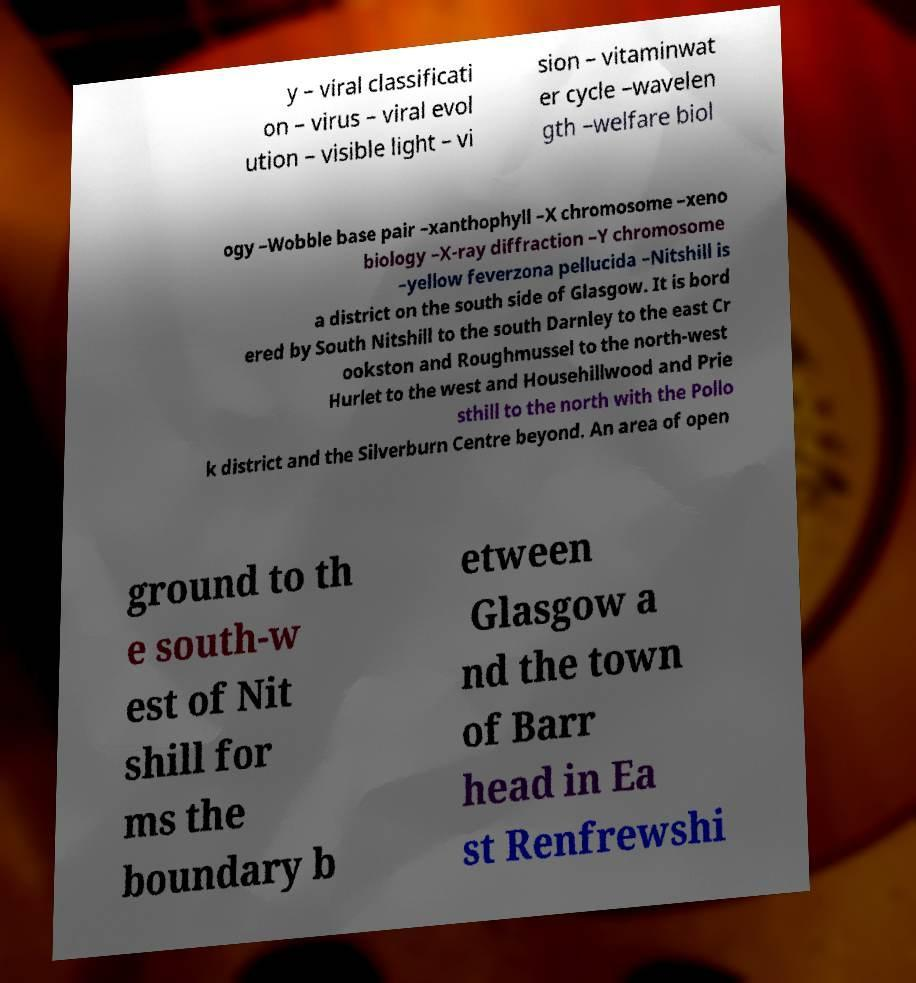Please identify and transcribe the text found in this image. y – viral classificati on – virus – viral evol ution – visible light – vi sion – vitaminwat er cycle –wavelen gth –welfare biol ogy –Wobble base pair –xanthophyll –X chromosome –xeno biology –X-ray diffraction –Y chromosome –yellow feverzona pellucida –Nitshill is a district on the south side of Glasgow. It is bord ered by South Nitshill to the south Darnley to the east Cr ookston and Roughmussel to the north-west Hurlet to the west and Househillwood and Prie sthill to the north with the Pollo k district and the Silverburn Centre beyond. An area of open ground to th e south-w est of Nit shill for ms the boundary b etween Glasgow a nd the town of Barr head in Ea st Renfrewshi 